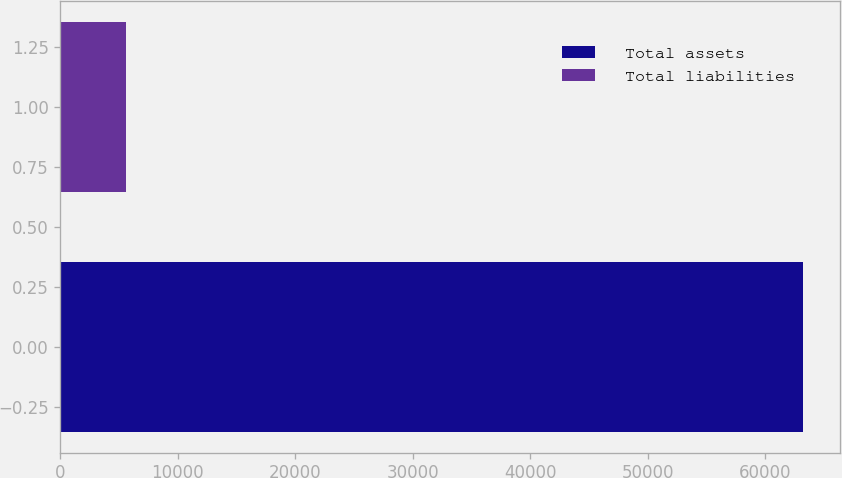<chart> <loc_0><loc_0><loc_500><loc_500><bar_chart><fcel>Total assets<fcel>Total liabilities<nl><fcel>63221<fcel>5585<nl></chart> 